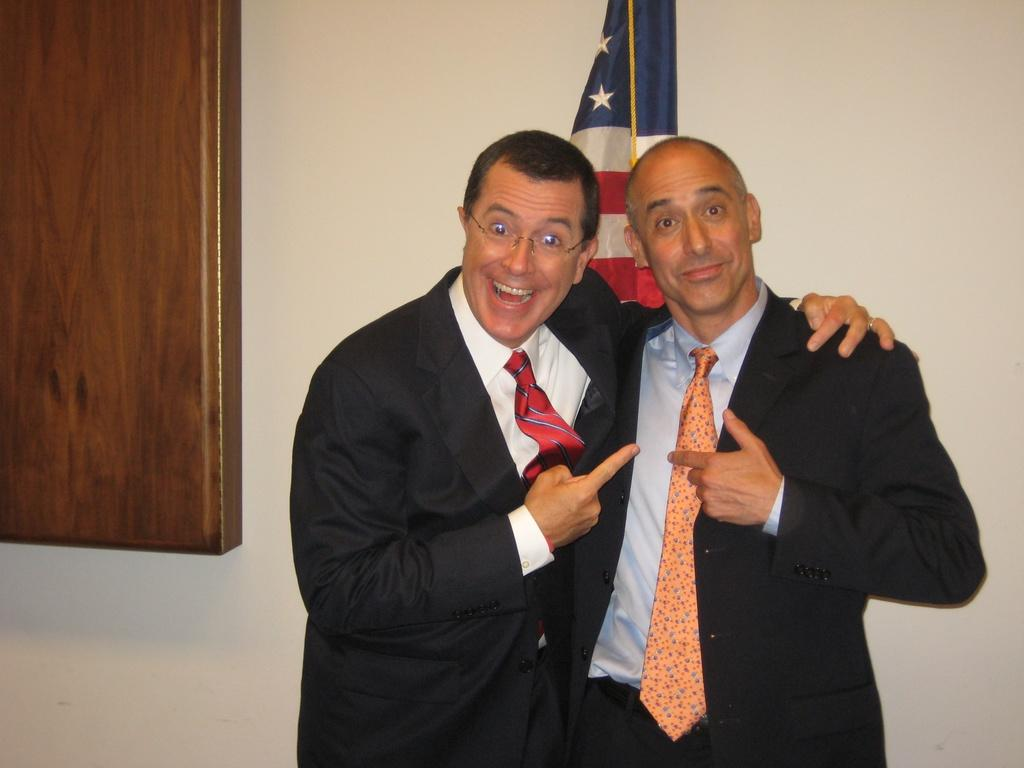How many people are in the image? There are two people standing in the center of the image. What are the people doing in the image? The people are smiling. What can be seen in the background of the image? There is a flag and a wall in the background of the image. What object is visible in the image? There is a board visible in the image. How many lizards are crawling on the board in the image? There are no lizards present in the image; the board is not mentioned as having any lizards on it. What type of spy equipment can be seen on the board in the image? There is no spy equipment visible on the board in the image. 